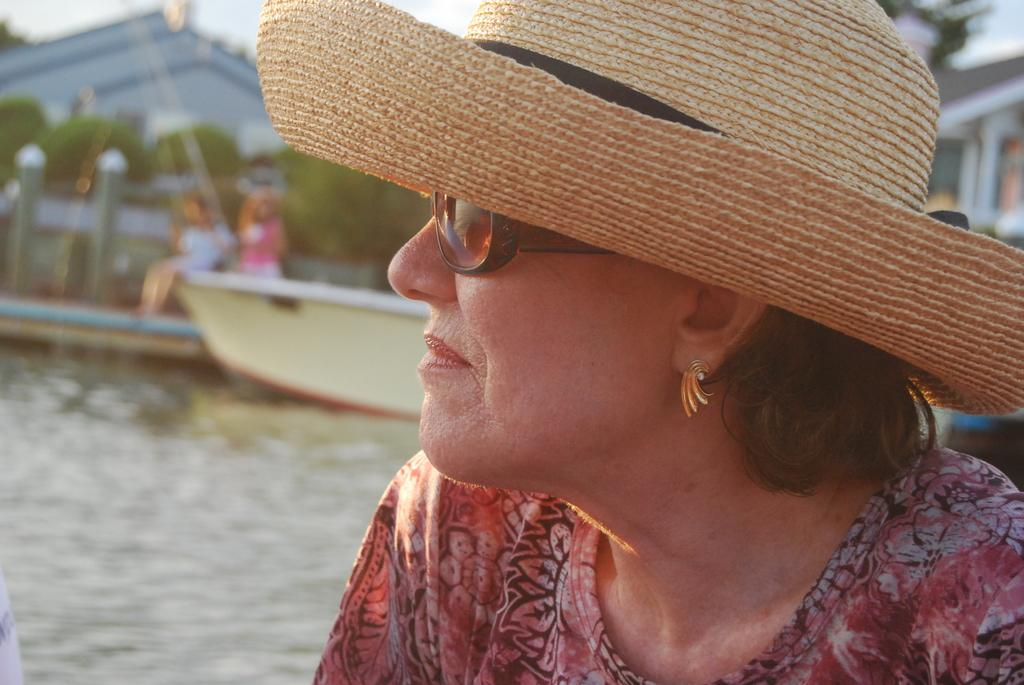What is the person in the foreground of the image wearing? The person in the image is wearing a hat and goggles. What can be seen in the background of the image? In the background, there is a boat on the water, two persons, buildings, plants, trees, and the sky. How many people are visible in the image? There is one person in the foreground and two persons in the background, making a total of three people visible in the image. What type of bone can be seen in the person's hand in the image? There is no bone visible in the person's hand in the image. What yard tool is being used by the person in the image? There is no yard tool present in the image. 